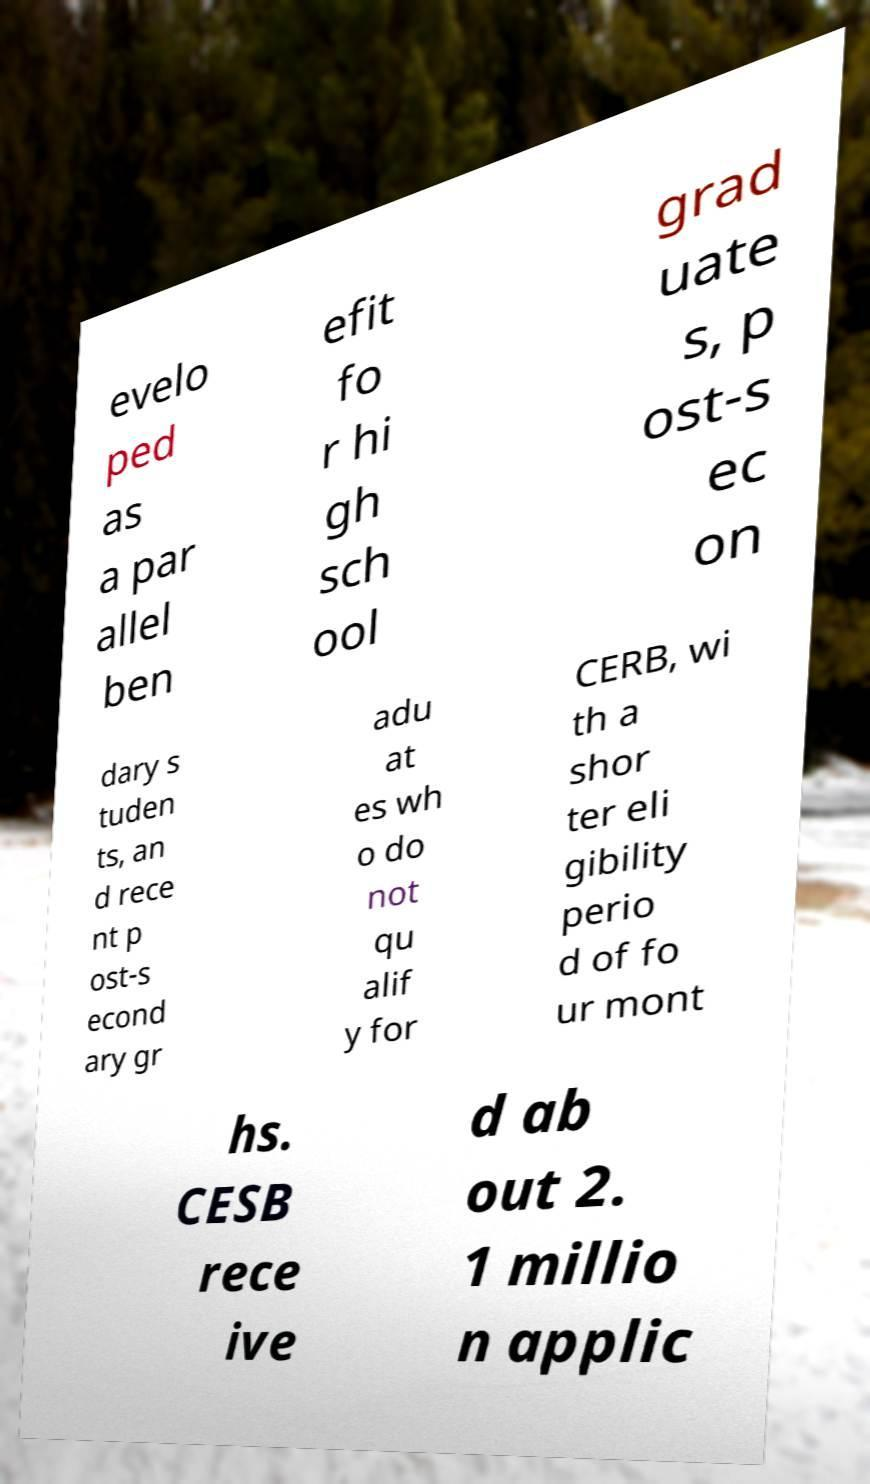Could you extract and type out the text from this image? evelo ped as a par allel ben efit fo r hi gh sch ool grad uate s, p ost-s ec on dary s tuden ts, an d rece nt p ost-s econd ary gr adu at es wh o do not qu alif y for CERB, wi th a shor ter eli gibility perio d of fo ur mont hs. CESB rece ive d ab out 2. 1 millio n applic 